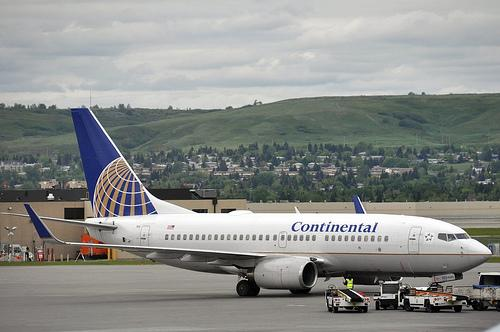Describe the weather and environment depicted in the image. The environment includes a cloudy sky, grass on the ground, and houses in the distance, with the airplane parked on a tarmac. What is the color and role of the person wearing a vest in the image? The person is wearing a neon yellow traffic vest and is likely a member of the ground support crew. How many window rows are present on the airplane? There is a row of small windows on the airplane. List the key elements present in the image and their activities. A white and blue jet airplane preparing for takeoff, ground support crew and vehicles on the tarmac, a person wearing a yellow vest, houses in the distance, cloudy sky, and grass on the ground. Identify the primary object in the image along with its notable features. A white and blue jet airplane on the tarmac with blue lettering on the side, a graphic on the tail, jet engine, landing gear, and multiple doors and windows. What is the position of the jet engine in relation to the wing of the airplane? The jet engine is located on the wing of the plane. Detect any prominent logos or markings on the airplane. There is a blue lettering on the side of the plane, a graphic on the tail, and a Continental logo. Mention any objects on the tarmac near the airplane. There are ground support crew, vehicles including an orange vehicle, and a person in a yellow vest on the tarmac near the airplane. Evaluate the overall quality of the image. The image is of adequate quality since it captures various details of the airplane, its surroundings, and the activity taking place, although there might be room for improvement with clearer focus on smaller elements. Analyze the sentiment conveyed by the image. The image conveys a sense of anticipation and preparation, as the airplane is getting ready for takeoff with the help of the ground support crew. What logotype is visible on the plane? continental logo Is there an American flag present in the image? If so, where is it located? Yes, there is an American flag near the back white door. Provide a description of the image that includes the location of the airplane. An airplane on the tarmac prepares for takeoff while crew and vehicles assist. Describe the expression of the person in the yellow vest. The expression is not visible. Is the large red door near the star logo on the plane positioned at X:407 Y:221 with a width of 15 and a height of 15? The instruction mentions a "red door," but the actual image has a "white door" at those described coordinates. Can you see a red flag on the white plane at X:164 Y:217 with a width of 13 and a height of 13? The instruction mentions a "red flag," but the actual image has an "american flag" at those described coordinates. What part of the airplane is the jet engine located on? wing of the plane Choose the correct statement about the image: a) There is a window on the roof of the plane. b) The airplane has white and blue paint. c) There are no visible windows in the image. b) The airplane has white and blue paint. Please list the locations of all the windows on the white plane. 1. window near cockpit What type of vehicle can be seen behind the plane? orange vehicle Does the airplane have a purple tail at X:69 Y:107 with a width of 102 and a height of 102? The instruction mentions a "purple tail," but the actual image has a "blue tail" on the white plane at those described coordinates. What are the features of the ground in the image? tarmac, grass, and vehicles on the tarmac Is there a pole in the distance, and if so, what color are its surroundings? Yes, there is a pole in the distance, and it is surrounded by blue. Is there a person wearing an orange vest at X:341 Y:271 with a width of 14 and a height of 14? The instruction mentions a "person wearing an orange vest," but the actual image has a "person wearing a yellow vest" at those described coordinates. Is there a black window in the cockpit of an airplane at X:453 Y:230 with a width of 16 and a height of 16? The instruction mentions a "black window," but the actual image has a "window in the cockpit" without specifying the color at those described coordinates. Identify the crew member's apparel in this scene. person in yellow vest What person can be seen near the airplane, and what are they wearing? A person wearing a yellow vest is near the airplane. Can you find a green word on the plane at X:289 Y:212 with a width of 92 and a height of 92? The instruction mentions a "green word," but the actual image has a "blue word" at those described coordinates. In the image, where are the houses located? in the distance Where are the small windows located on the airplane? in a row on the side What is the main subject of the image? a white and blue jet airplane Explain which part of the airplane has a blue paint job. the tail and lettering on the side Describe the color and logo of the airplane. The airplane is white and blue with a continental logo. Write a caption for the image using an adjective to describe the sky. An airplane preparing for takeoff under a cloudy sky. What is placed in between the engine and door on the plane's side? tires and a black tire near the white engine Select the best caption for the image: a) A green airplane parked in the hanger. b) A person wearing a red vest waving at the airplane. c) A white and blue jet airplane with people and vehicles on the tarmac. c) A white and blue jet airplane with people and vehicles on the tarmac. 